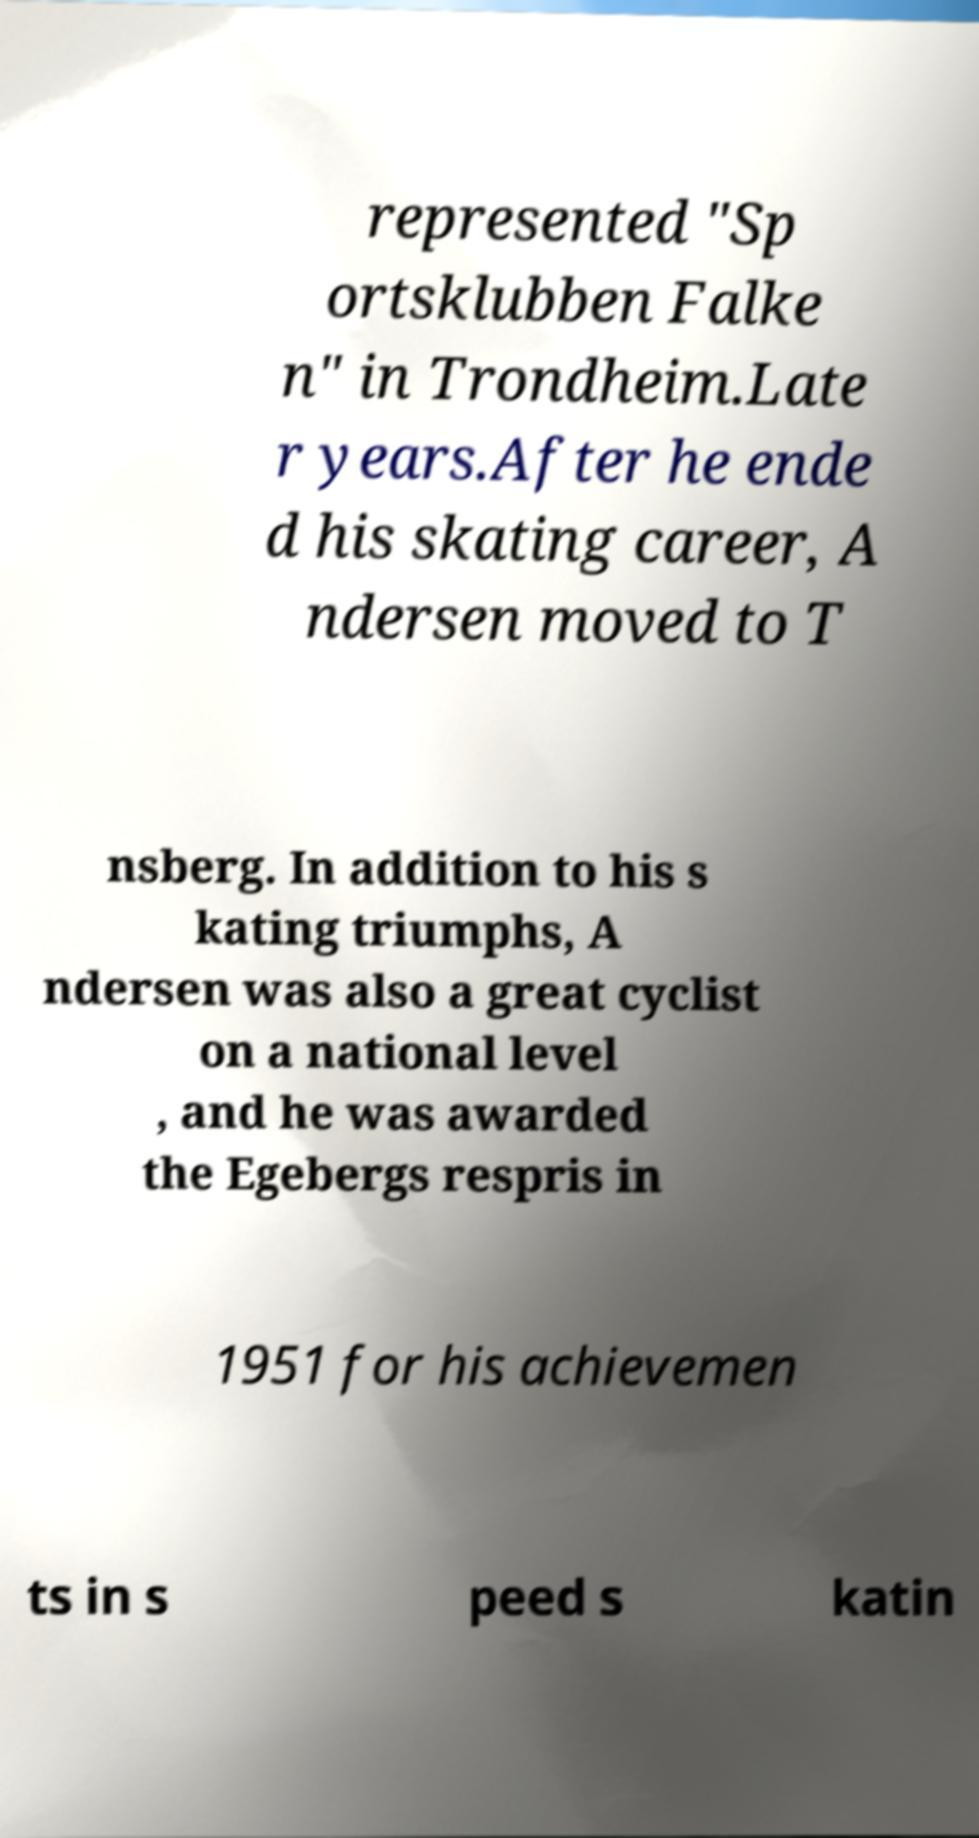Could you extract and type out the text from this image? represented "Sp ortsklubben Falke n" in Trondheim.Late r years.After he ende d his skating career, A ndersen moved to T nsberg. In addition to his s kating triumphs, A ndersen was also a great cyclist on a national level , and he was awarded the Egebergs respris in 1951 for his achievemen ts in s peed s katin 